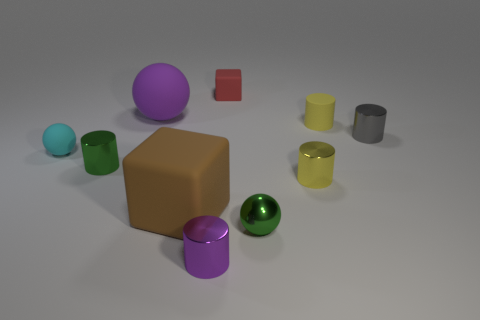There is a large ball; is its color the same as the metallic cylinder in front of the brown object? Indeed, the large purple ball shares the same color hue as the small metallic cylinder positioned before the sizeable brown cube. 